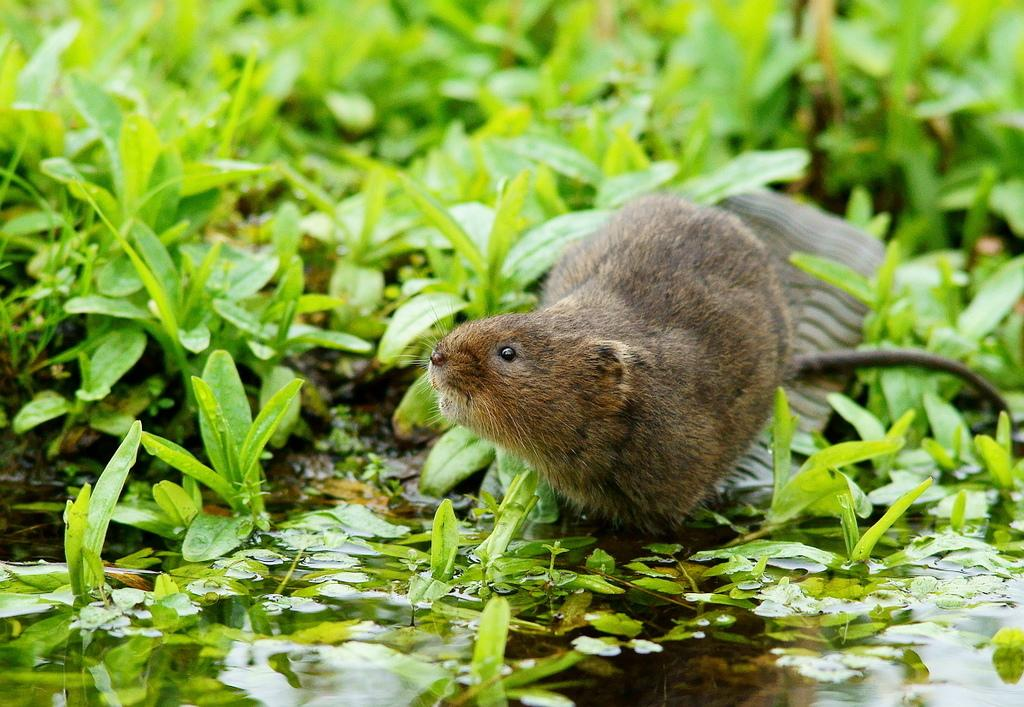What type of creature is in the image? There is an animal in the image. What color is the animal? The animal is brown in color. What other elements can be seen in the image besides the animal? There are plants and water visible in the image. What historical event is depicted in the image? There is no historical event depicted in the image; it features an animal, plants, and water. What type of beetle can be seen in the image? There is no beetle present in the image. 